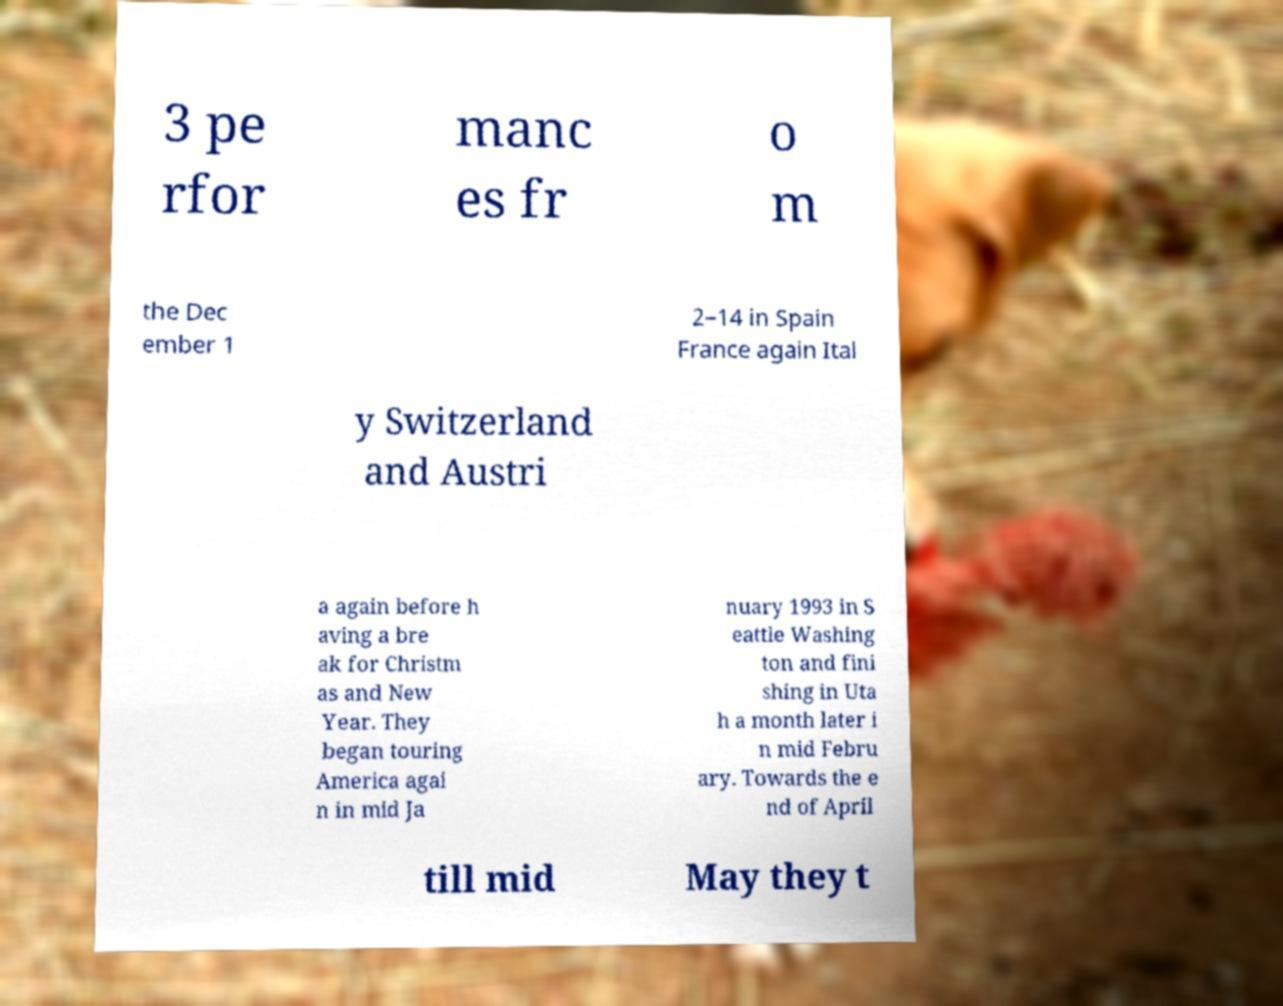Please read and relay the text visible in this image. What does it say? 3 pe rfor manc es fr o m the Dec ember 1 2–14 in Spain France again Ital y Switzerland and Austri a again before h aving a bre ak for Christm as and New Year. They began touring America agai n in mid Ja nuary 1993 in S eattle Washing ton and fini shing in Uta h a month later i n mid Febru ary. Towards the e nd of April till mid May they t 